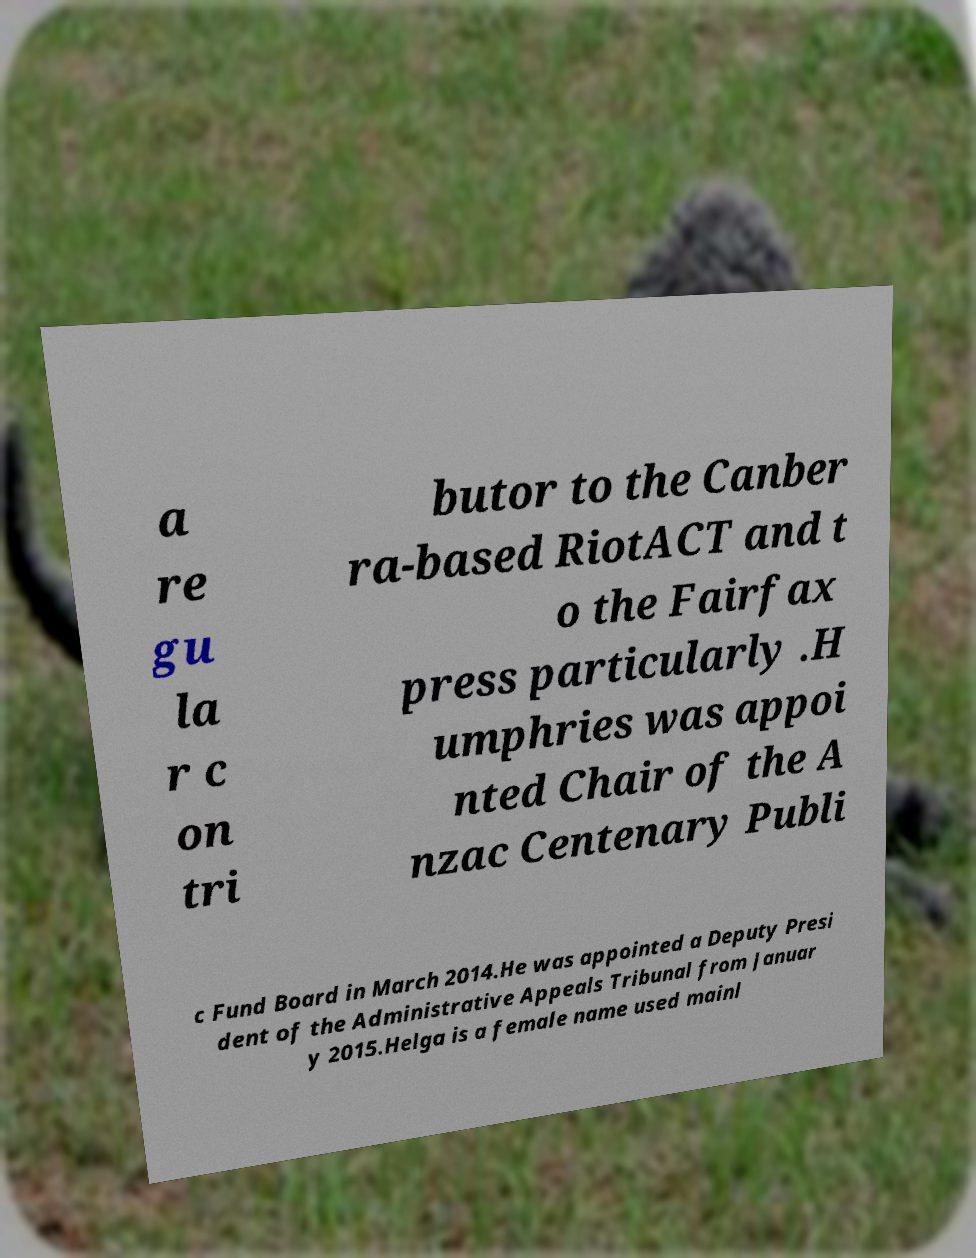Could you extract and type out the text from this image? a re gu la r c on tri butor to the Canber ra-based RiotACT and t o the Fairfax press particularly .H umphries was appoi nted Chair of the A nzac Centenary Publi c Fund Board in March 2014.He was appointed a Deputy Presi dent of the Administrative Appeals Tribunal from Januar y 2015.Helga is a female name used mainl 